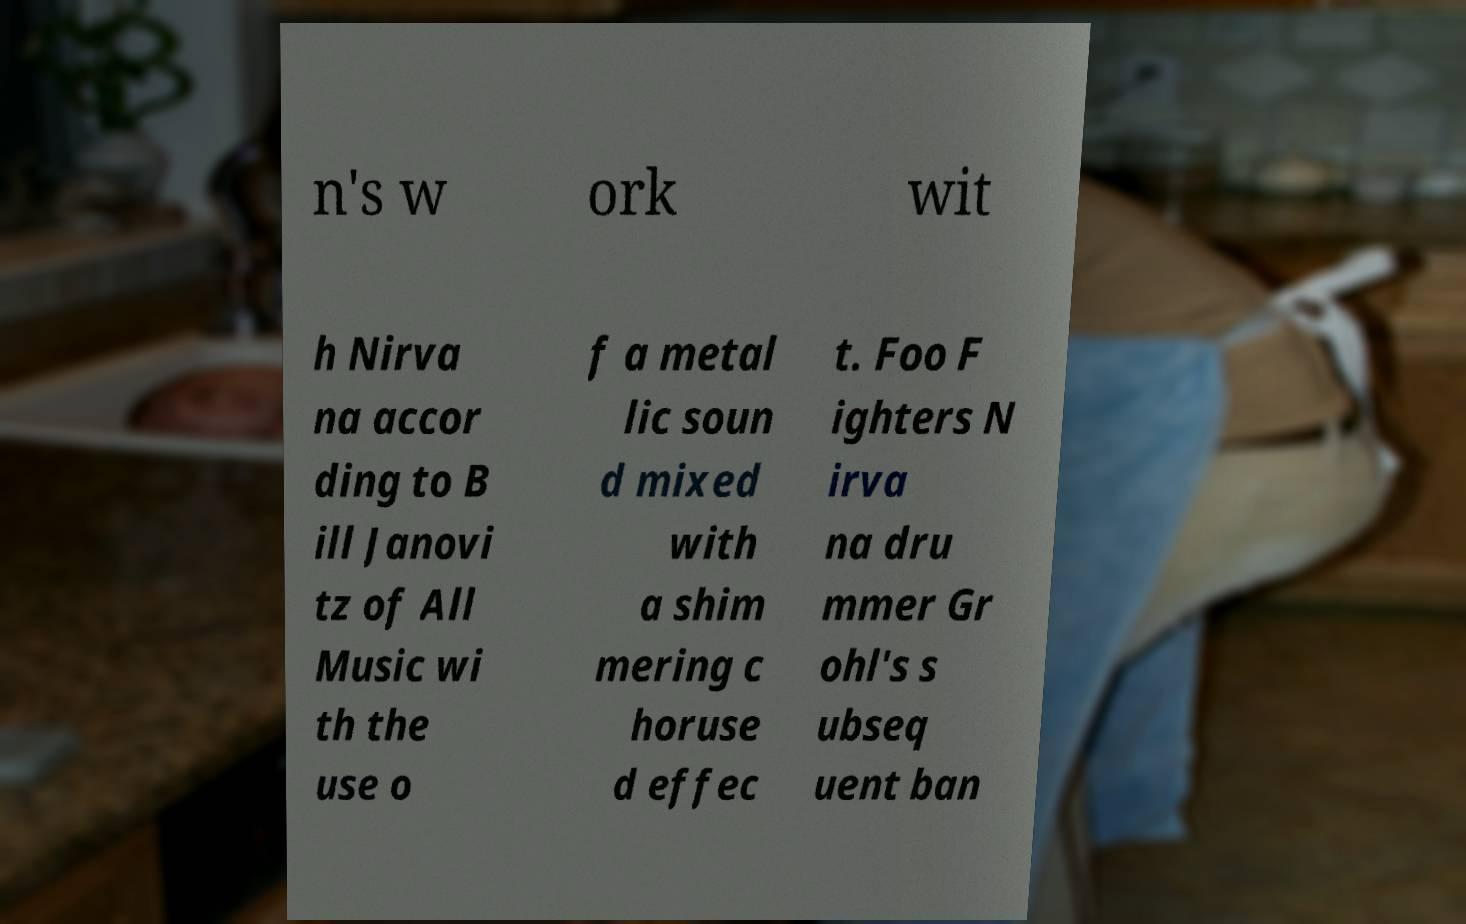Could you extract and type out the text from this image? n's w ork wit h Nirva na accor ding to B ill Janovi tz of All Music wi th the use o f a metal lic soun d mixed with a shim mering c horuse d effec t. Foo F ighters N irva na dru mmer Gr ohl's s ubseq uent ban 